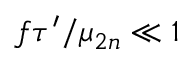Convert formula to latex. <formula><loc_0><loc_0><loc_500><loc_500>f \tau ^ { \prime } / \mu _ { 2 n } \ll 1</formula> 